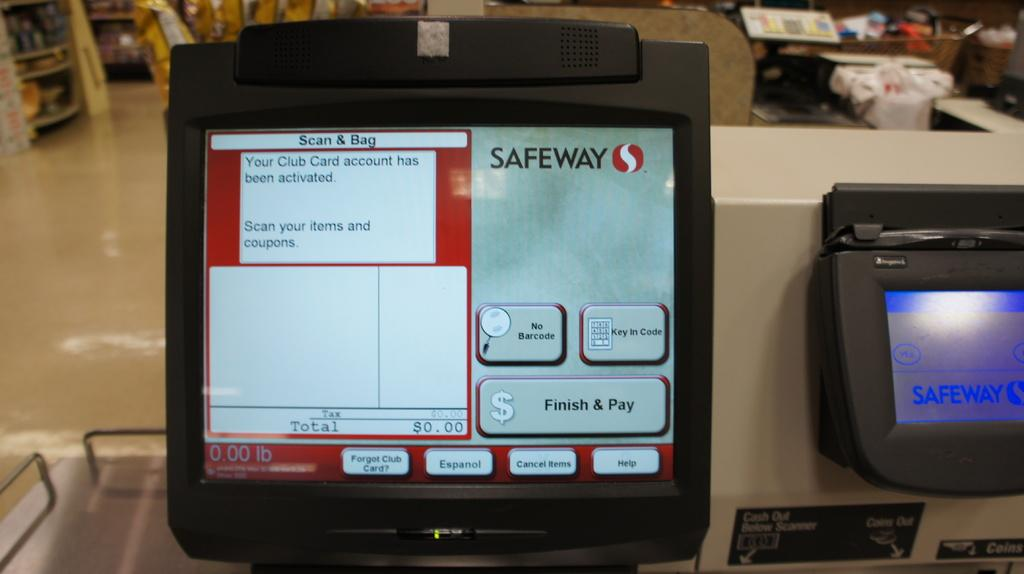<image>
Offer a succinct explanation of the picture presented. A scanning machine for Safeway states the club card is activated. 